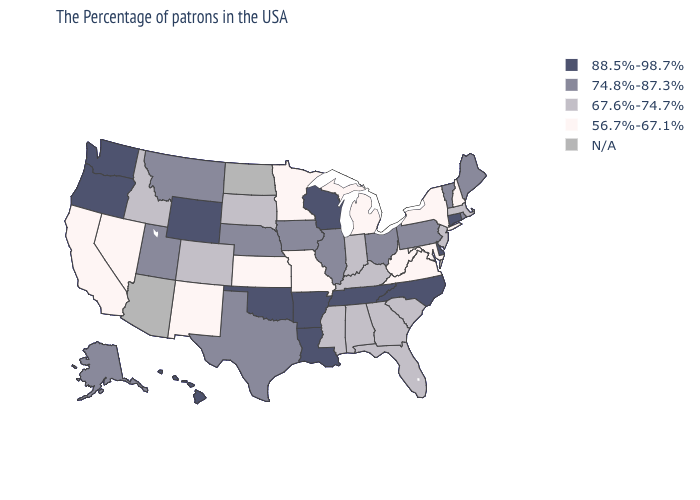What is the highest value in the USA?
Quick response, please. 88.5%-98.7%. Which states have the lowest value in the MidWest?
Short answer required. Michigan, Missouri, Minnesota, Kansas. Among the states that border Louisiana , which have the highest value?
Be succinct. Arkansas. Name the states that have a value in the range 56.7%-67.1%?
Keep it brief. New Hampshire, New York, Maryland, Virginia, West Virginia, Michigan, Missouri, Minnesota, Kansas, New Mexico, Nevada, California. What is the highest value in the USA?
Write a very short answer. 88.5%-98.7%. What is the value of Delaware?
Keep it brief. 88.5%-98.7%. What is the lowest value in the West?
Give a very brief answer. 56.7%-67.1%. What is the value of Maine?
Write a very short answer. 74.8%-87.3%. What is the lowest value in states that border Massachusetts?
Keep it brief. 56.7%-67.1%. How many symbols are there in the legend?
Quick response, please. 5. What is the highest value in the USA?
Concise answer only. 88.5%-98.7%. What is the highest value in states that border Georgia?
Write a very short answer. 88.5%-98.7%. Which states have the lowest value in the West?
Short answer required. New Mexico, Nevada, California. 